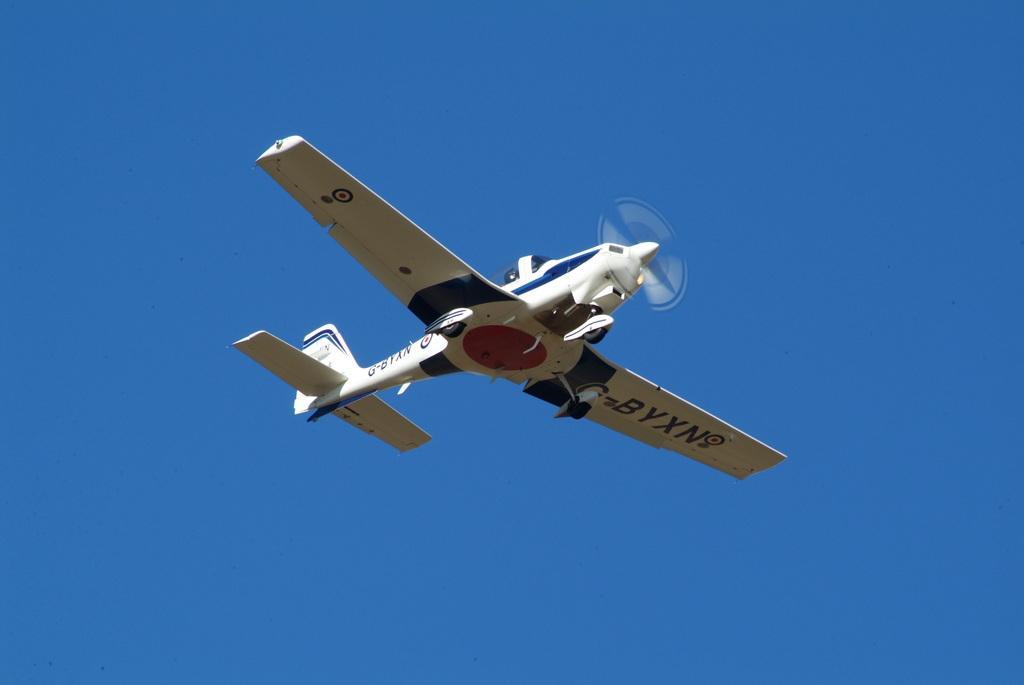How would you summarize this image in a sentence or two? In the center of the picture there is an aircraft flying. Sky is sunny. 